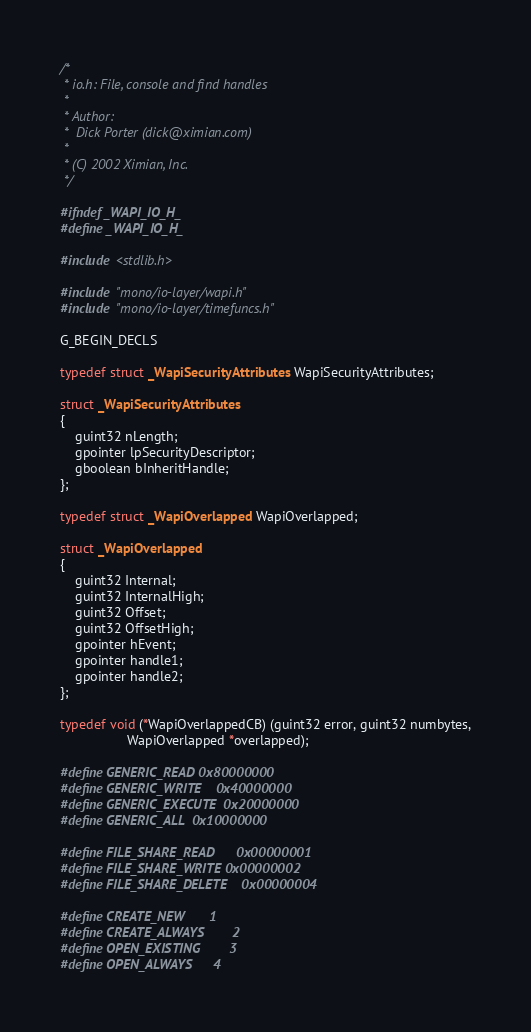<code> <loc_0><loc_0><loc_500><loc_500><_C_>/*
 * io.h: File, console and find handles
 *
 * Author:
 *	Dick Porter (dick@ximian.com)
 *
 * (C) 2002 Ximian, Inc.
 */

#ifndef _WAPI_IO_H_
#define _WAPI_IO_H_

#include <stdlib.h>

#include "mono/io-layer/wapi.h"
#include "mono/io-layer/timefuncs.h"

G_BEGIN_DECLS

typedef struct _WapiSecurityAttributes WapiSecurityAttributes;

struct _WapiSecurityAttributes 
{
	guint32 nLength;
	gpointer lpSecurityDescriptor;
	gboolean bInheritHandle;
};

typedef struct _WapiOverlapped WapiOverlapped;

struct _WapiOverlapped
{
	guint32 Internal;
	guint32 InternalHigh;
	guint32 Offset;
	guint32 OffsetHigh;
	gpointer hEvent;
	gpointer handle1;
	gpointer handle2;
};

typedef void (*WapiOverlappedCB) (guint32 error, guint32 numbytes,
				  WapiOverlapped *overlapped);

#define GENERIC_READ	0x80000000
#define GENERIC_WRITE	0x40000000
#define GENERIC_EXECUTE	0x20000000
#define GENERIC_ALL	0x10000000

#define FILE_SHARE_READ		0x00000001
#define FILE_SHARE_WRITE	0x00000002
#define FILE_SHARE_DELETE	0x00000004

#define CREATE_NEW		1
#define CREATE_ALWAYS		2
#define OPEN_EXISTING		3
#define OPEN_ALWAYS		4</code> 